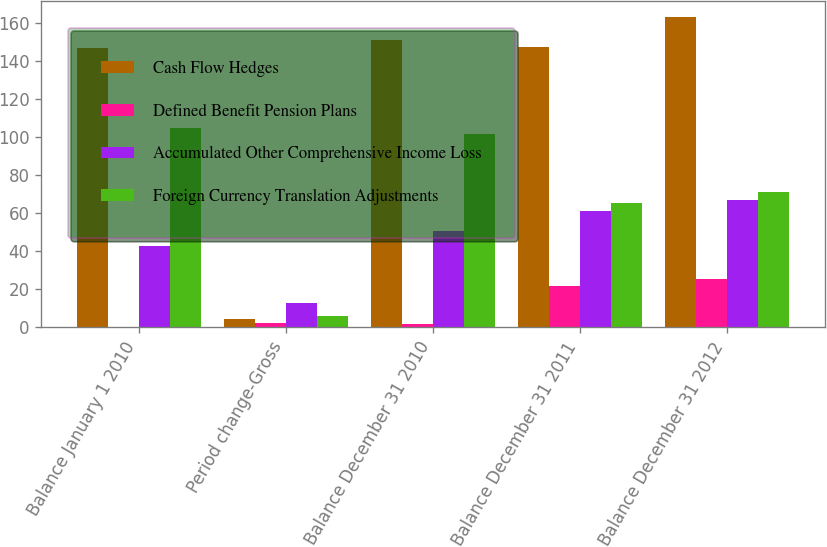Convert chart to OTSL. <chart><loc_0><loc_0><loc_500><loc_500><stacked_bar_chart><ecel><fcel>Balance January 1 2010<fcel>Period change-Gross<fcel>Balance December 31 2010<fcel>Balance December 31 2011<fcel>Balance December 31 2012<nl><fcel>Cash Flow Hedges<fcel>147.2<fcel>4.5<fcel>151.1<fcel>147.6<fcel>163.5<nl><fcel>Defined Benefit Pension Plans<fcel>0.1<fcel>2.2<fcel>1.4<fcel>21.5<fcel>25.5<nl><fcel>Accumulated Other Comprehensive Income Loss<fcel>42.5<fcel>12.7<fcel>50.7<fcel>60.9<fcel>67<nl><fcel>Foreign Currency Translation Adjustments<fcel>104.8<fcel>6<fcel>101.8<fcel>65.2<fcel>71<nl></chart> 